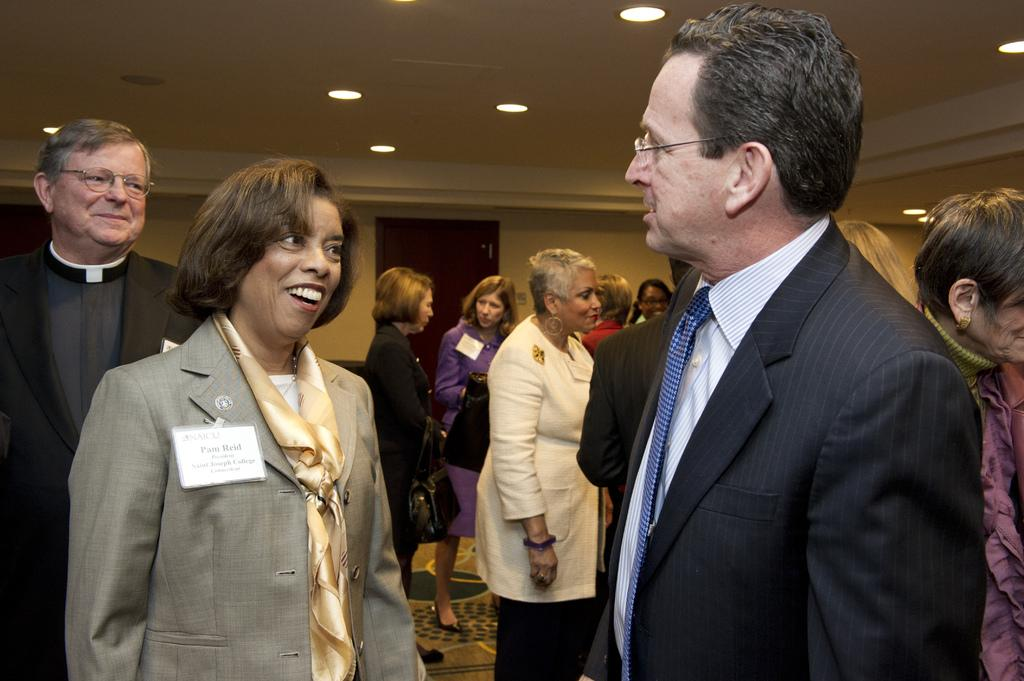How many people are in the image? There are people in the image, but the exact number is not specified. What are the people doing in the image? The people are standing and talking to each other. What type of pen is the parent using to write in the image? There is no parent or pen present in the image. What is the man doing while talking to the other people in the image? The facts do not specify any individual person or their actions beyond talking to each other. 